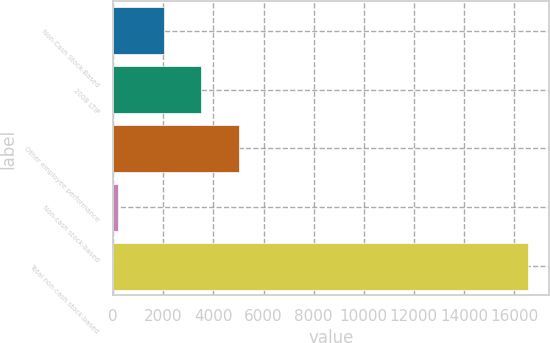Convert chart to OTSL. <chart><loc_0><loc_0><loc_500><loc_500><bar_chart><fcel>Non-Cash Stock-Based<fcel>2008 LTIP<fcel>Other employee performance<fcel>Non-cash stock-based<fcel>Total non-cash stock-based<nl><fcel>2013<fcel>3520.1<fcel>5027.2<fcel>182<fcel>16578.1<nl></chart> 